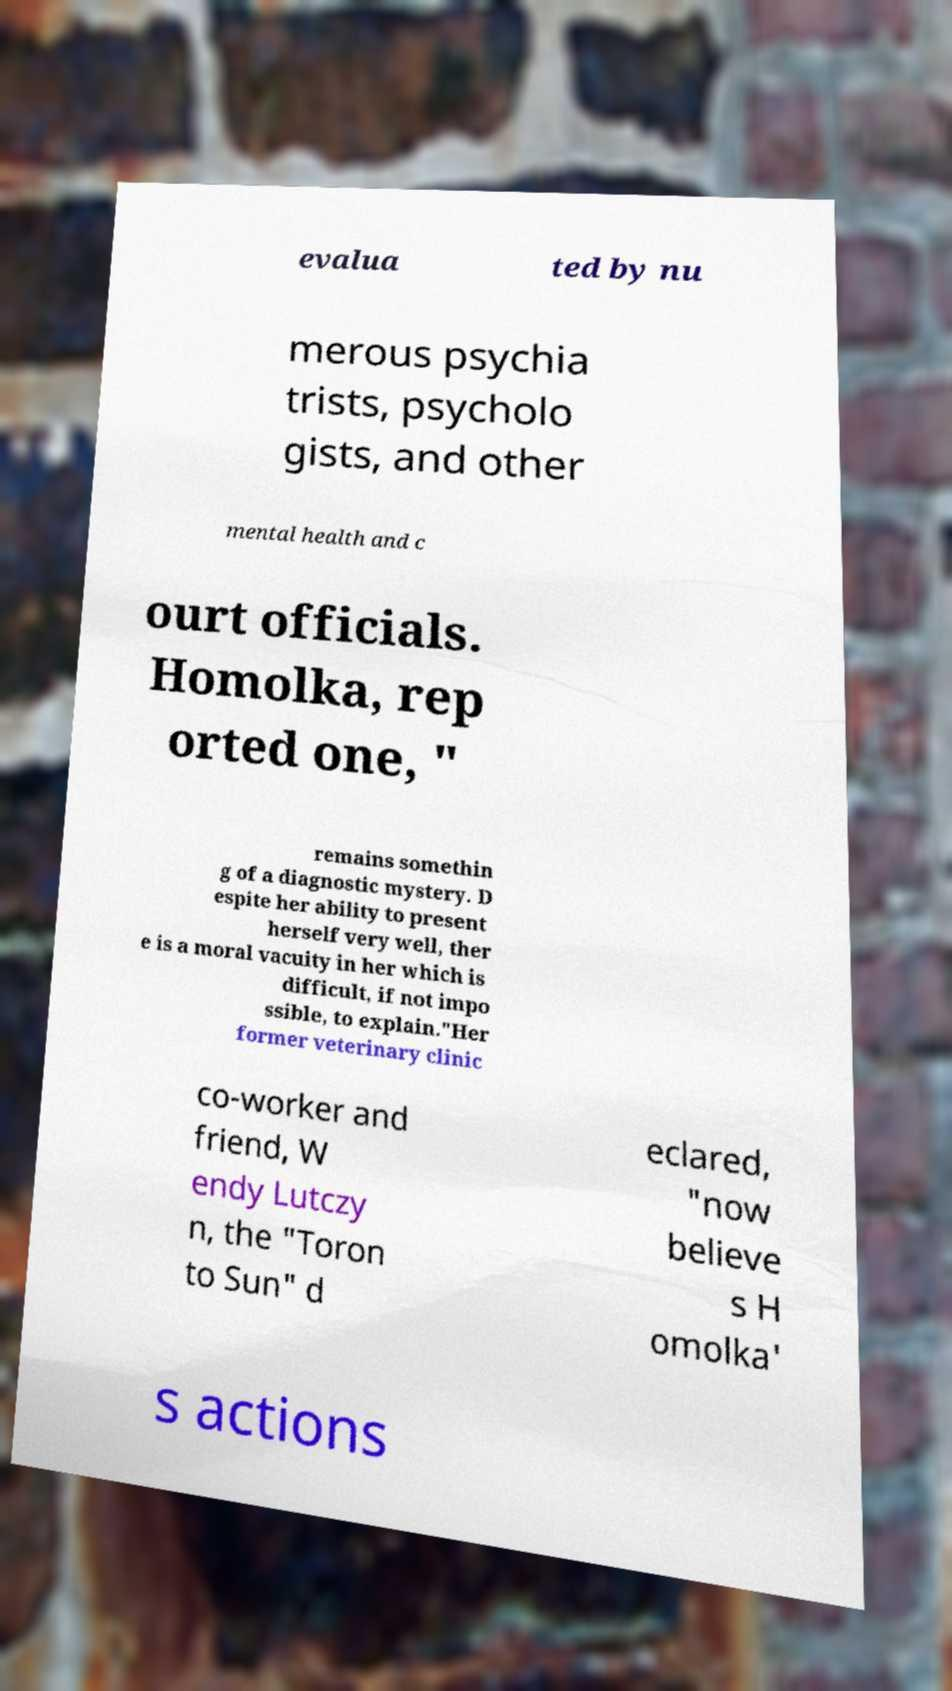Please read and relay the text visible in this image. What does it say? evalua ted by nu merous psychia trists, psycholo gists, and other mental health and c ourt officials. Homolka, rep orted one, " remains somethin g of a diagnostic mystery. D espite her ability to present herself very well, ther e is a moral vacuity in her which is difficult, if not impo ssible, to explain."Her former veterinary clinic co-worker and friend, W endy Lutczy n, the "Toron to Sun" d eclared, "now believe s H omolka' s actions 